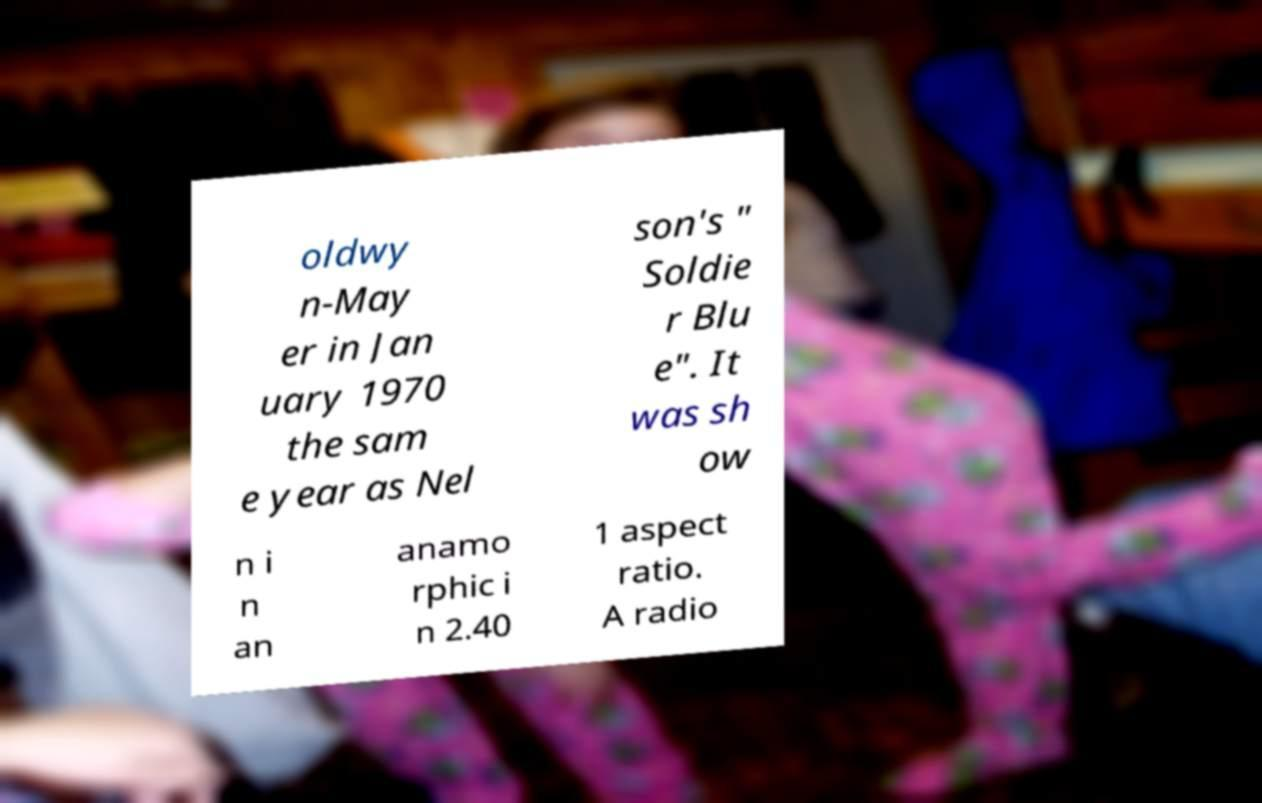I need the written content from this picture converted into text. Can you do that? oldwy n-May er in Jan uary 1970 the sam e year as Nel son's " Soldie r Blu e". It was sh ow n i n an anamo rphic i n 2.40 1 aspect ratio. A radio 